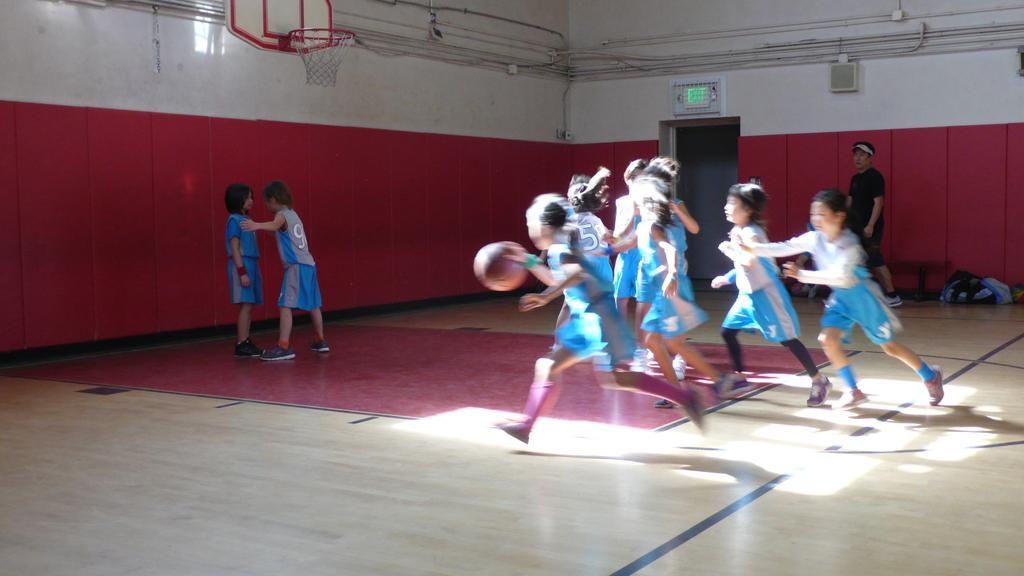How would you summarize this image in a sentence or two? In this image we can see people on the floor and one of them is holding a ball in the hand. In the background there are pipelines, electric lights, speakers and a basket attached to the wall. 